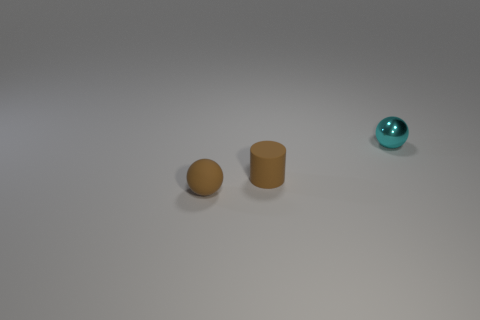Is there anything else that has the same material as the cyan thing?
Offer a very short reply. No. Are there an equal number of things that are behind the tiny cyan ball and gray rubber cylinders?
Your response must be concise. Yes. How many other things are there of the same material as the brown cylinder?
Your answer should be very brief. 1. Is the size of the sphere that is left of the cyan thing the same as the rubber object right of the brown sphere?
Offer a very short reply. Yes. How many things are tiny objects in front of the cyan metallic ball or tiny objects behind the cylinder?
Make the answer very short. 3. Is there any other thing that is the same shape as the small cyan thing?
Your answer should be compact. Yes. There is a small matte object on the right side of the rubber ball; is its color the same as the small sphere on the right side of the brown ball?
Ensure brevity in your answer.  No. How many metal objects are either spheres or brown things?
Your answer should be very brief. 1. The brown object right of the sphere that is in front of the cyan object is what shape?
Keep it short and to the point. Cylinder. Does the tiny ball to the left of the tiny metallic object have the same material as the brown object to the right of the rubber sphere?
Make the answer very short. Yes. 